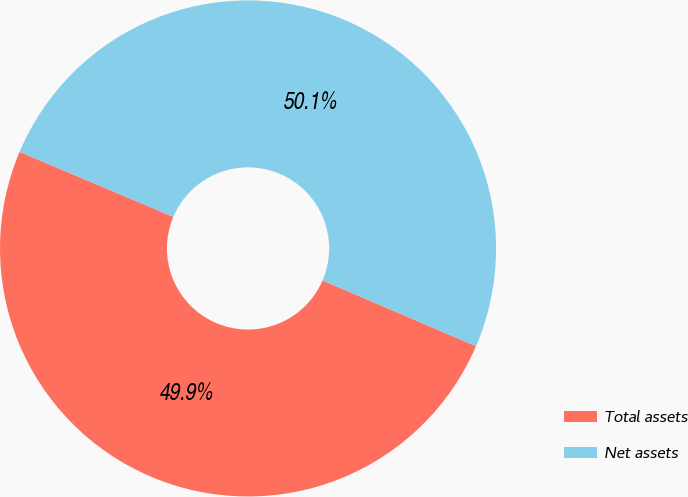Convert chart. <chart><loc_0><loc_0><loc_500><loc_500><pie_chart><fcel>Total assets<fcel>Net assets<nl><fcel>49.92%<fcel>50.08%<nl></chart> 